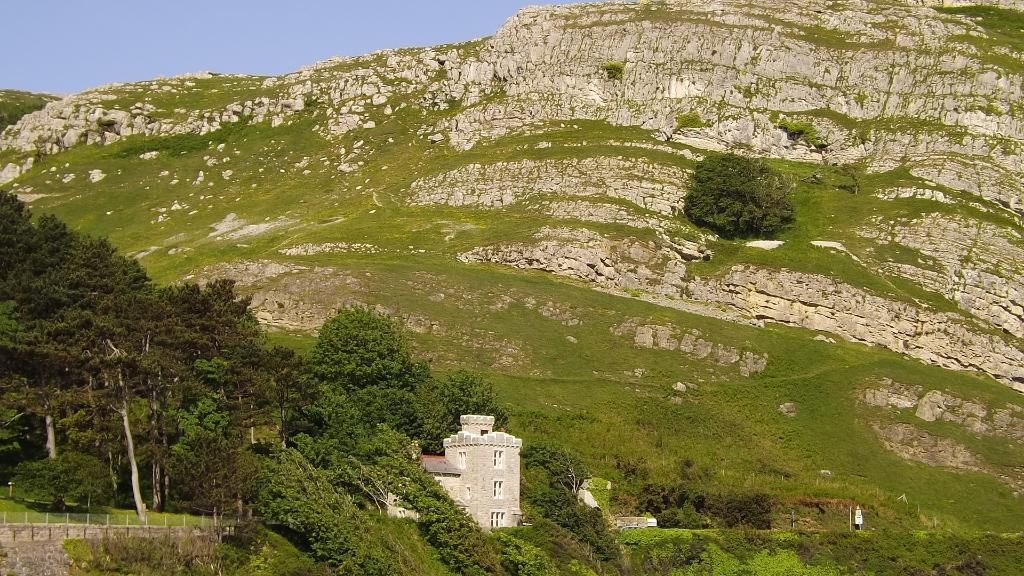What type of natural landscape can be seen in the image? There are hills in the image. What other elements are present in the image besides the hills? There are trees and buildings in the image. What can be seen in the background of the image? The sky is visible in the background of the image. How many wishes can be granted by the trees in the image? Trees do not grant wishes, so this question cannot be answered. 